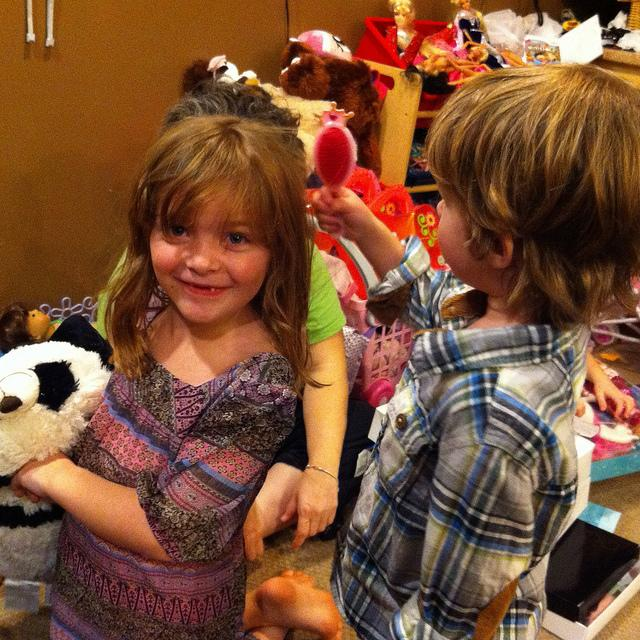What is the design called on the boy's shirt?

Choices:
A) polka dot
B) striped
C) flannel
D) plaid flannel 